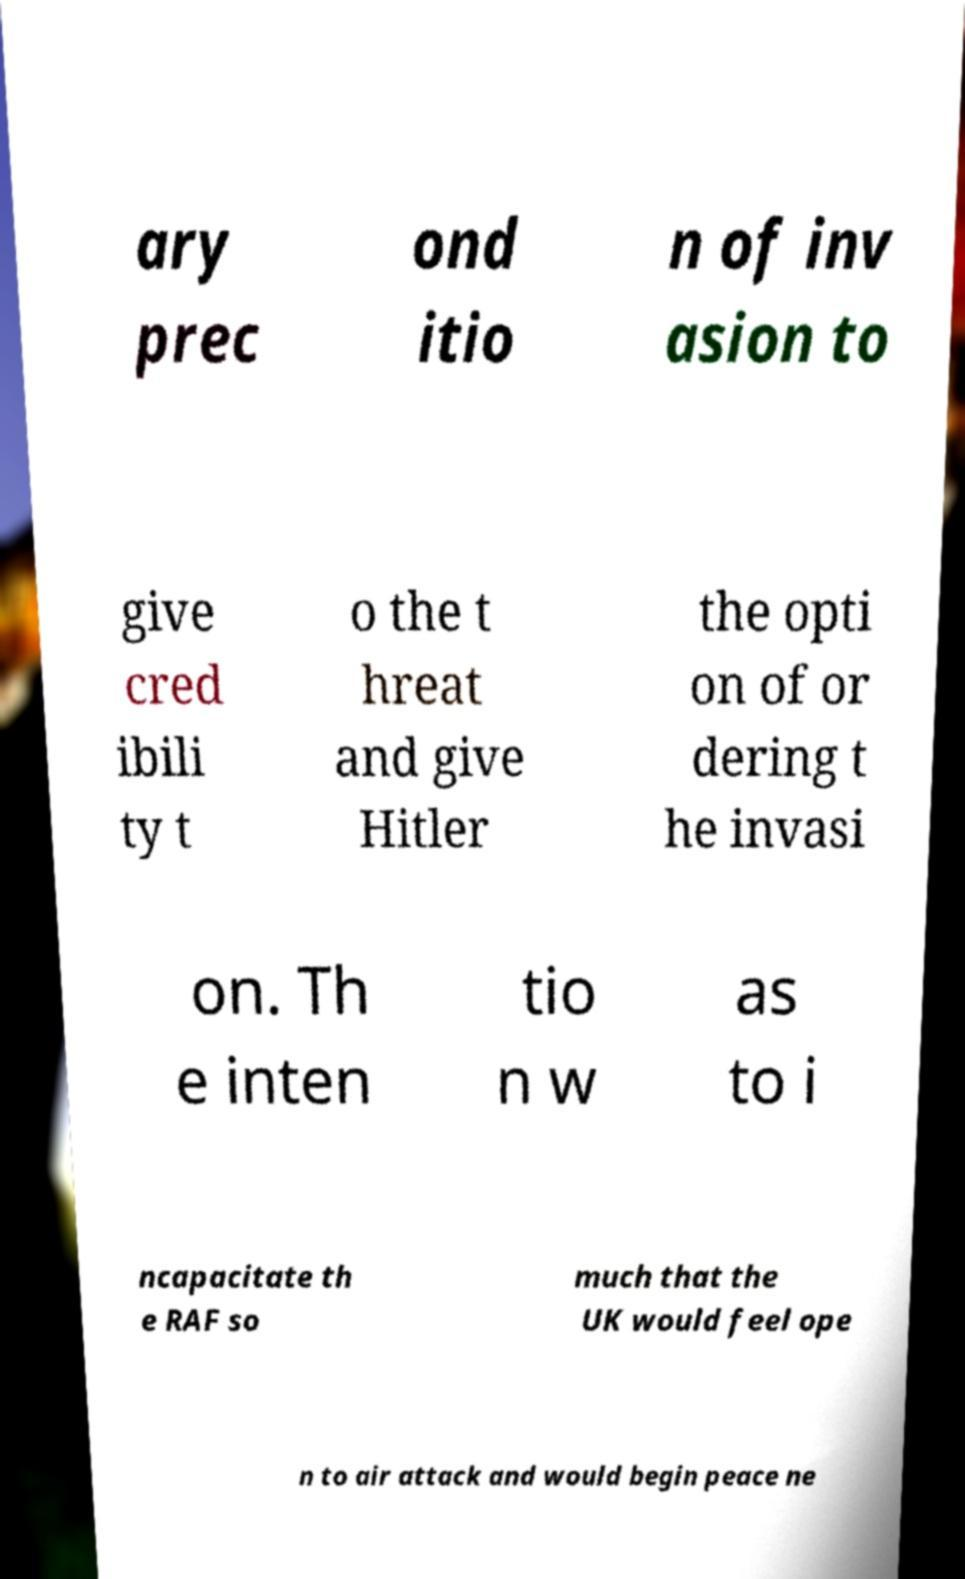Can you read and provide the text displayed in the image?This photo seems to have some interesting text. Can you extract and type it out for me? ary prec ond itio n of inv asion to give cred ibili ty t o the t hreat and give Hitler the opti on of or dering t he invasi on. Th e inten tio n w as to i ncapacitate th e RAF so much that the UK would feel ope n to air attack and would begin peace ne 